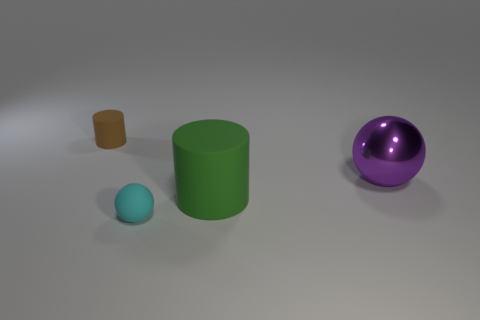Add 2 large cubes. How many objects exist? 6 Add 1 tiny matte cylinders. How many tiny matte cylinders exist? 2 Subtract 0 gray cylinders. How many objects are left? 4 Subtract all tiny blue rubber things. Subtract all tiny cylinders. How many objects are left? 3 Add 4 brown objects. How many brown objects are left? 5 